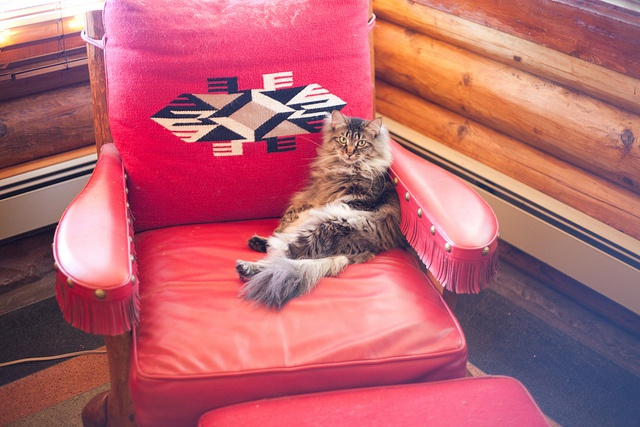Describe the objects in this image and their specific colors. I can see chair in white, salmon, lightpink, and brown tones and cat in white, gray, brown, lightgray, and lightpink tones in this image. 